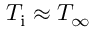<formula> <loc_0><loc_0><loc_500><loc_500>T _ { i } \approx T _ { \infty }</formula> 